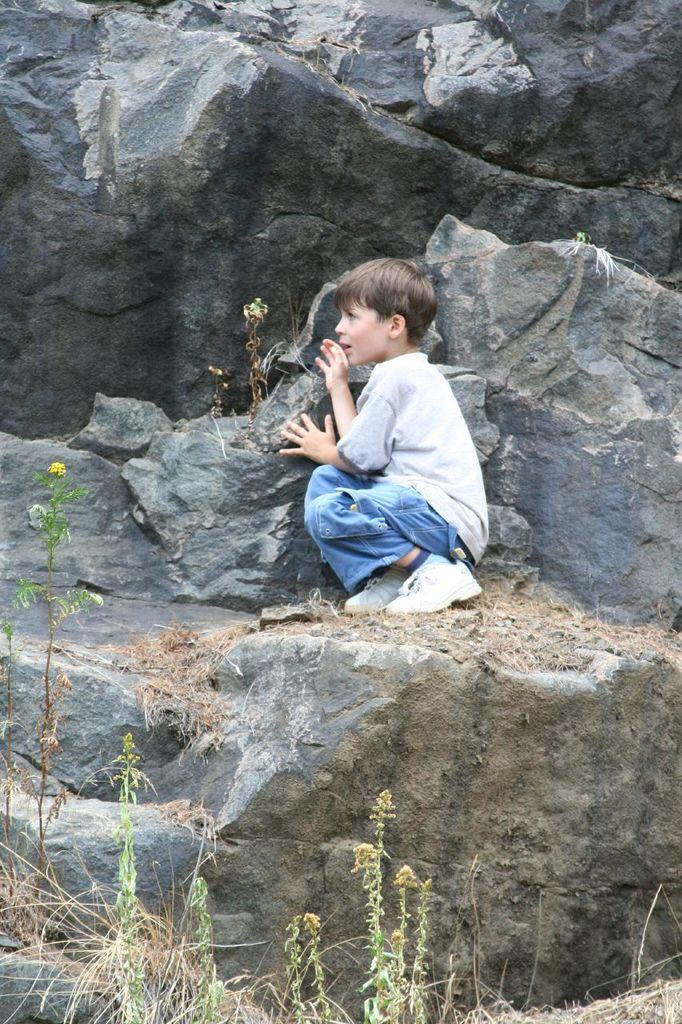Who is the main subject in the image? There is a boy in the image. What is the boy wearing? The boy is wearing a white T-shirt. Where is the boy sitting? The boy is sitting on a rock. What type of vegetation is present at the bottom of the image? There are plants and grass at the bottom of the image. What can be seen in the background of the image? There are rocks in the background of the image. How many ducks are swimming in the water near the boy in the image? There is no water or ducks present in the image; it features a boy sitting on a rock with plants and grass at the bottom. What type of zipper can be seen on the boy's pants in the image? The boy is wearing a white T-shirt, and there is no mention of pants or zippers in the provided facts. 